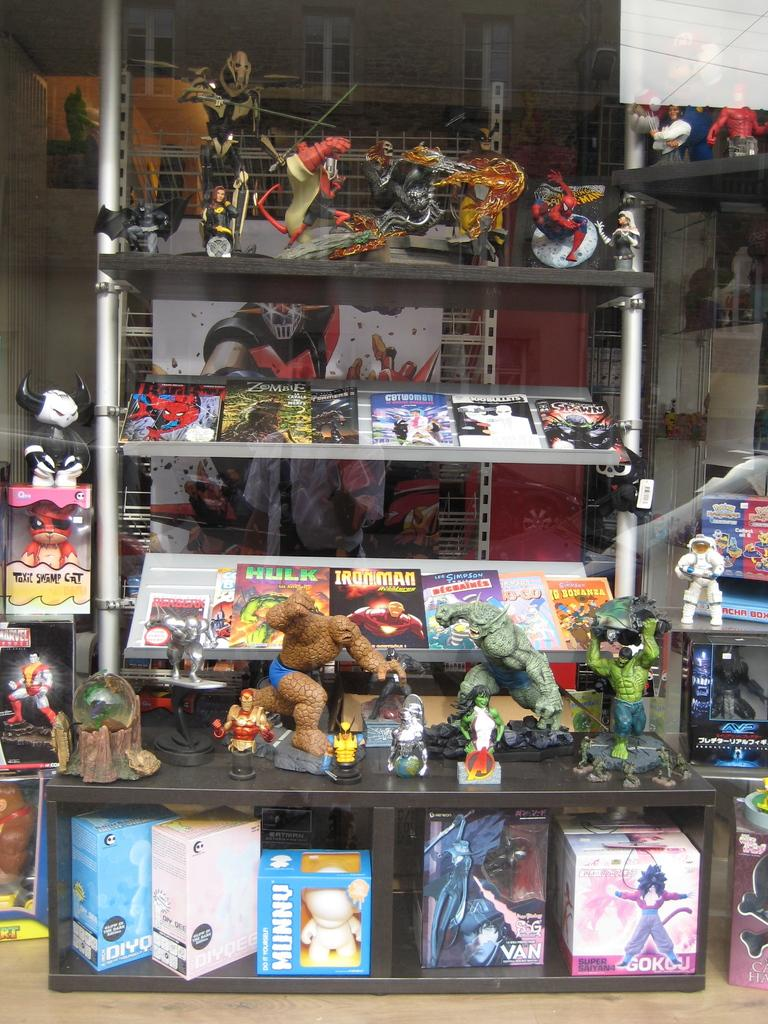<image>
Give a short and clear explanation of the subsequent image. A box on the lower shelf on the right side says Gokou. 